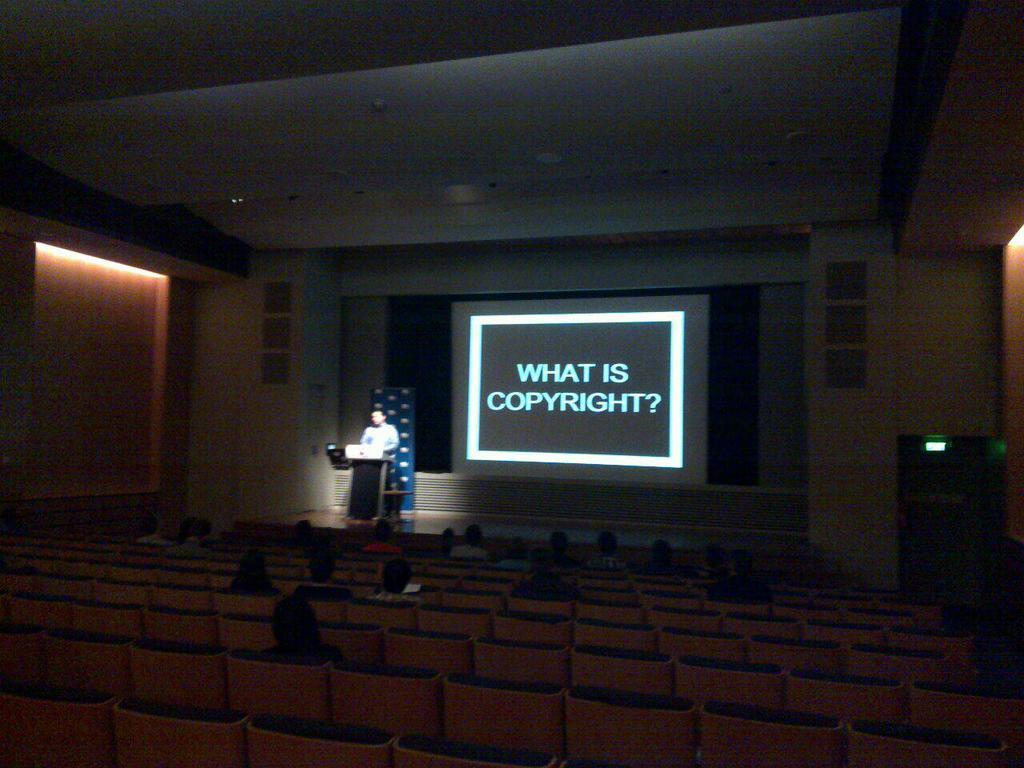What are the people in the image doing? The people in the image are sitting on chairs. Is there anyone standing in the image? Yes, there is a person standing at the back. What is the standing person positioned near? The standing person is positioned near a speech desk. What can be seen on the projector display in the image? Unfortunately, the content of the projector display cannot be determined from the image. Can you see any tomatoes being raked by the person standing in the image? There are no tomatoes or rakes present in the image. Is the person standing in the image looking at their self in a mirror? There is no mirror visible in the image, and the person's actions cannot be determined from the provided facts. 